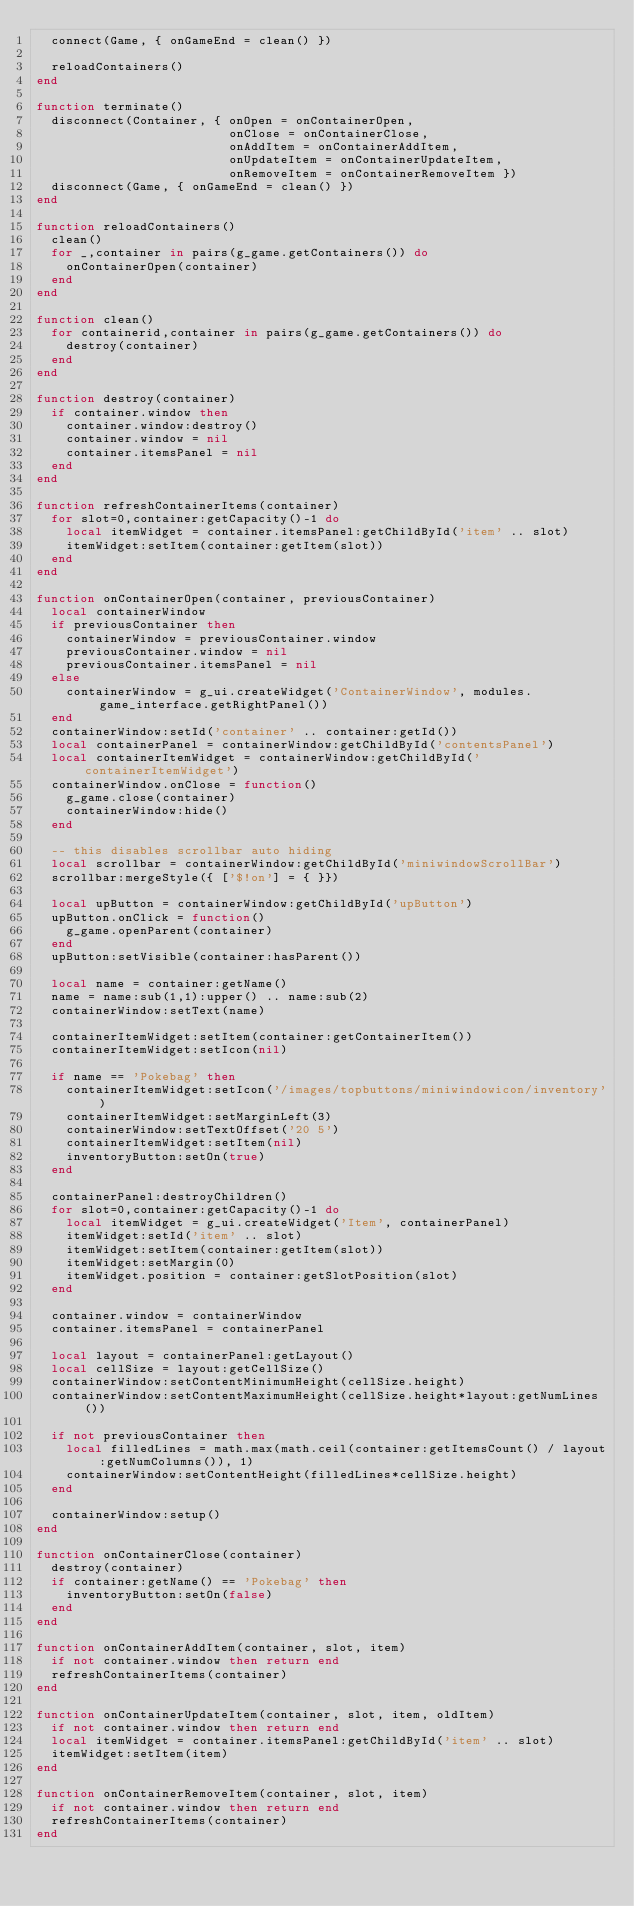<code> <loc_0><loc_0><loc_500><loc_500><_Lua_>  connect(Game, { onGameEnd = clean() })

  reloadContainers()
end

function terminate()
  disconnect(Container, { onOpen = onContainerOpen,
                          onClose = onContainerClose,
                          onAddItem = onContainerAddItem,
                          onUpdateItem = onContainerUpdateItem,
                          onRemoveItem = onContainerRemoveItem })
  disconnect(Game, { onGameEnd = clean() })
end

function reloadContainers()
  clean()
  for _,container in pairs(g_game.getContainers()) do
    onContainerOpen(container)
  end
end

function clean()
  for containerid,container in pairs(g_game.getContainers()) do
    destroy(container)
  end
end

function destroy(container)
  if container.window then
    container.window:destroy()
    container.window = nil
    container.itemsPanel = nil
  end
end

function refreshContainerItems(container)
  for slot=0,container:getCapacity()-1 do
    local itemWidget = container.itemsPanel:getChildById('item' .. slot)
    itemWidget:setItem(container:getItem(slot))
  end
end

function onContainerOpen(container, previousContainer)
  local containerWindow
  if previousContainer then
    containerWindow = previousContainer.window
    previousContainer.window = nil
    previousContainer.itemsPanel = nil
  else
    containerWindow = g_ui.createWidget('ContainerWindow', modules.game_interface.getRightPanel())
  end
  containerWindow:setId('container' .. container:getId())
  local containerPanel = containerWindow:getChildById('contentsPanel')
  local containerItemWidget = containerWindow:getChildById('containerItemWidget')
  containerWindow.onClose = function()
    g_game.close(container)
    containerWindow:hide()
  end

  -- this disables scrollbar auto hiding
  local scrollbar = containerWindow:getChildById('miniwindowScrollBar')
  scrollbar:mergeStyle({ ['$!on'] = { }})

  local upButton = containerWindow:getChildById('upButton')
  upButton.onClick = function()
    g_game.openParent(container)
  end
  upButton:setVisible(container:hasParent())

  local name = container:getName()
  name = name:sub(1,1):upper() .. name:sub(2)
  containerWindow:setText(name)

  containerItemWidget:setItem(container:getContainerItem())
  containerItemWidget:setIcon(nil)

  if name == 'Pokebag' then
    containerItemWidget:setIcon('/images/topbuttons/miniwindowicon/inventory')
    containerItemWidget:setMarginLeft(3)
    containerWindow:setTextOffset('20 5')
    containerItemWidget:setItem(nil)
    inventoryButton:setOn(true)
  end

  containerPanel:destroyChildren()
  for slot=0,container:getCapacity()-1 do
    local itemWidget = g_ui.createWidget('Item', containerPanel)
    itemWidget:setId('item' .. slot)
    itemWidget:setItem(container:getItem(slot))
    itemWidget:setMargin(0)
    itemWidget.position = container:getSlotPosition(slot)
  end

  container.window = containerWindow
  container.itemsPanel = containerPanel

  local layout = containerPanel:getLayout()
  local cellSize = layout:getCellSize()
  containerWindow:setContentMinimumHeight(cellSize.height)
  containerWindow:setContentMaximumHeight(cellSize.height*layout:getNumLines())

  if not previousContainer then
    local filledLines = math.max(math.ceil(container:getItemsCount() / layout:getNumColumns()), 1)
    containerWindow:setContentHeight(filledLines*cellSize.height)
  end

  containerWindow:setup()
end

function onContainerClose(container)
  destroy(container)
  if container:getName() == 'Pokebag' then
    inventoryButton:setOn(false)
  end
end

function onContainerAddItem(container, slot, item)
  if not container.window then return end
  refreshContainerItems(container)
end

function onContainerUpdateItem(container, slot, item, oldItem)
  if not container.window then return end
  local itemWidget = container.itemsPanel:getChildById('item' .. slot)
  itemWidget:setItem(item)
end

function onContainerRemoveItem(container, slot, item)
  if not container.window then return end
  refreshContainerItems(container)
end
</code> 